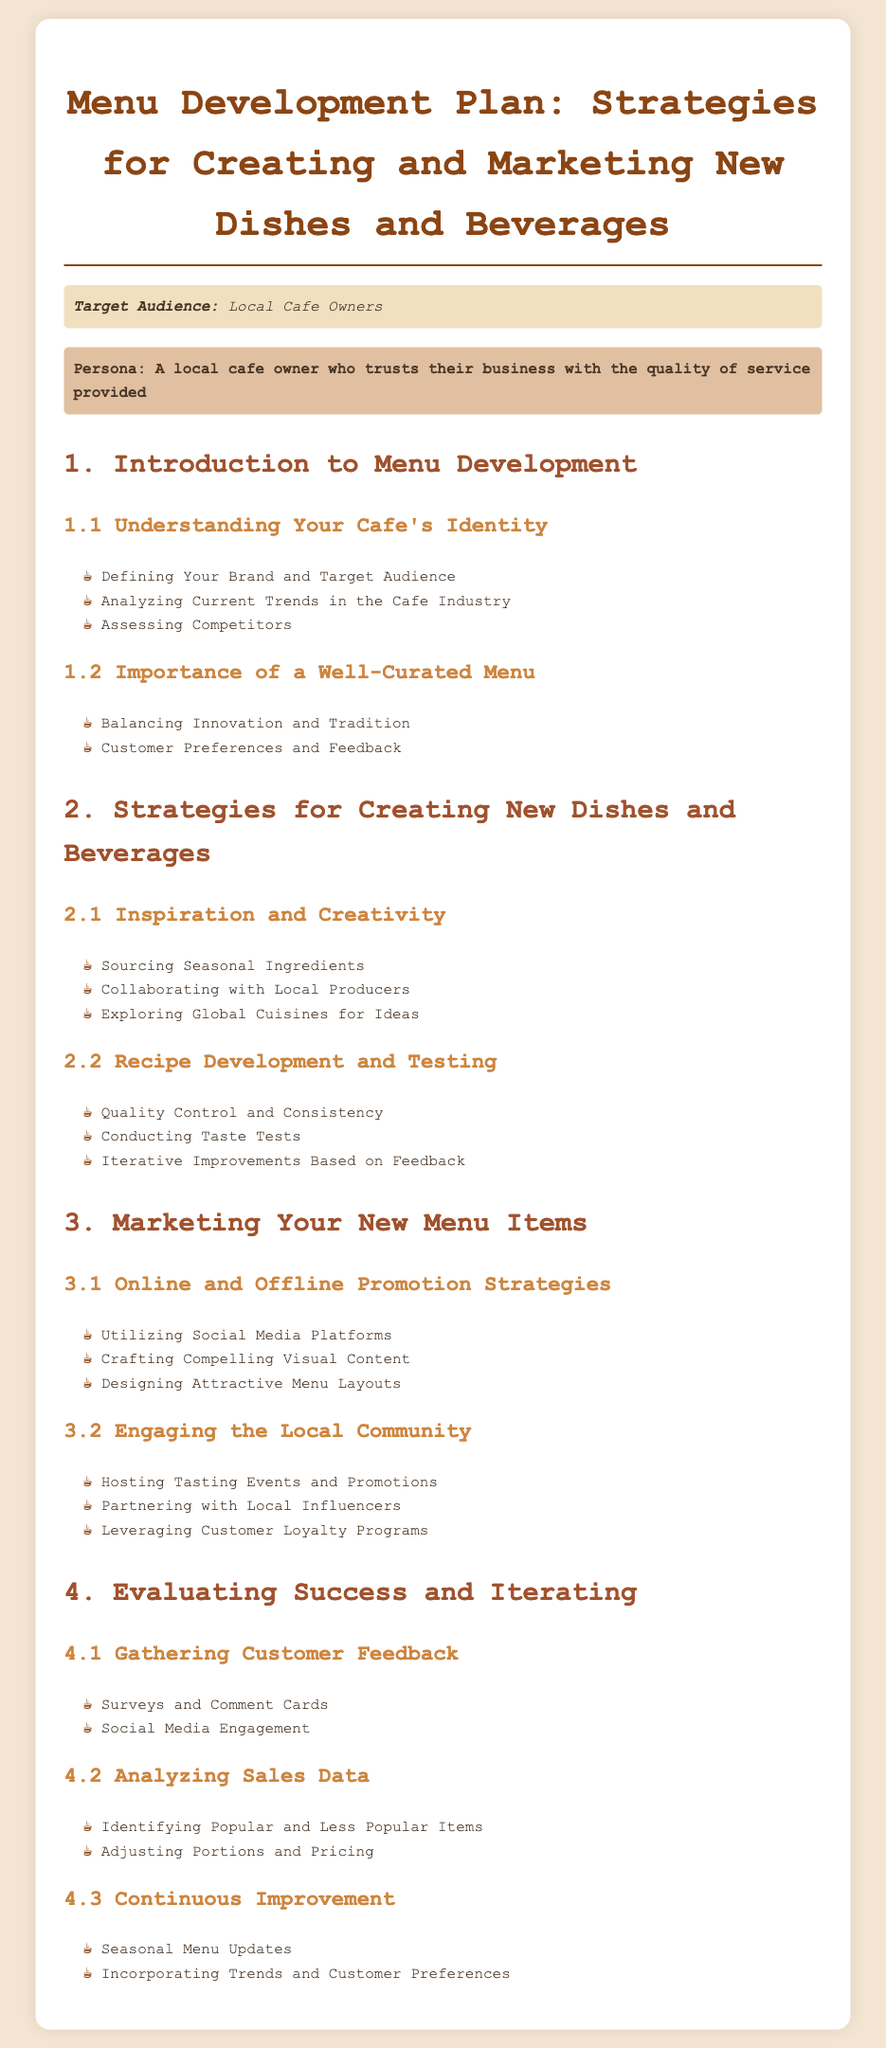what is the title of the document? The title is stated at the top of the syllabus document.
Answer: Menu Development Plan: Strategies for Creating and Marketing New Dishes and Beverages who is the target audience for this syllabus? The target audience section specifies who the syllabus is intended for.
Answer: Local Cafe Owners what is one way to gather customer feedback mentioned in the document? The document lists a few methods under the gathering customer feedback section.
Answer: Surveys and Comment Cards name one strategy for creating new dishes and beverages. The strategies for creating new dishes are outlined in the second section of the document.
Answer: Sourcing Seasonal Ingredients how many main sections are in the syllabus? The number of main sections is identified in the document's structure.
Answer: 4 what is the focus of section 3.2? The title of section 3.2 indicates its focus area.
Answer: Engaging the Local Community which type of promotions does the document suggest for marketing new menu items? The document specifies types of promotions in the marketing section.
Answer: Tasting Events and Promotions what is mentioned as important in section 1.2? Section 1.2 outlines a crucial aspect of menu development.
Answer: Importance of a Well-Curated Menu 